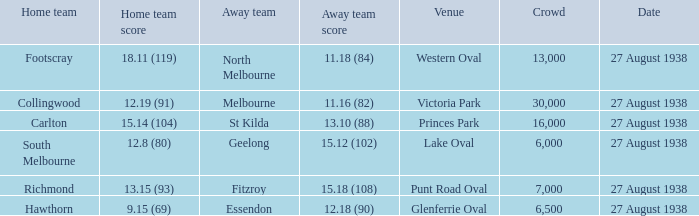Which Team plays at Western Oval? Footscray. 